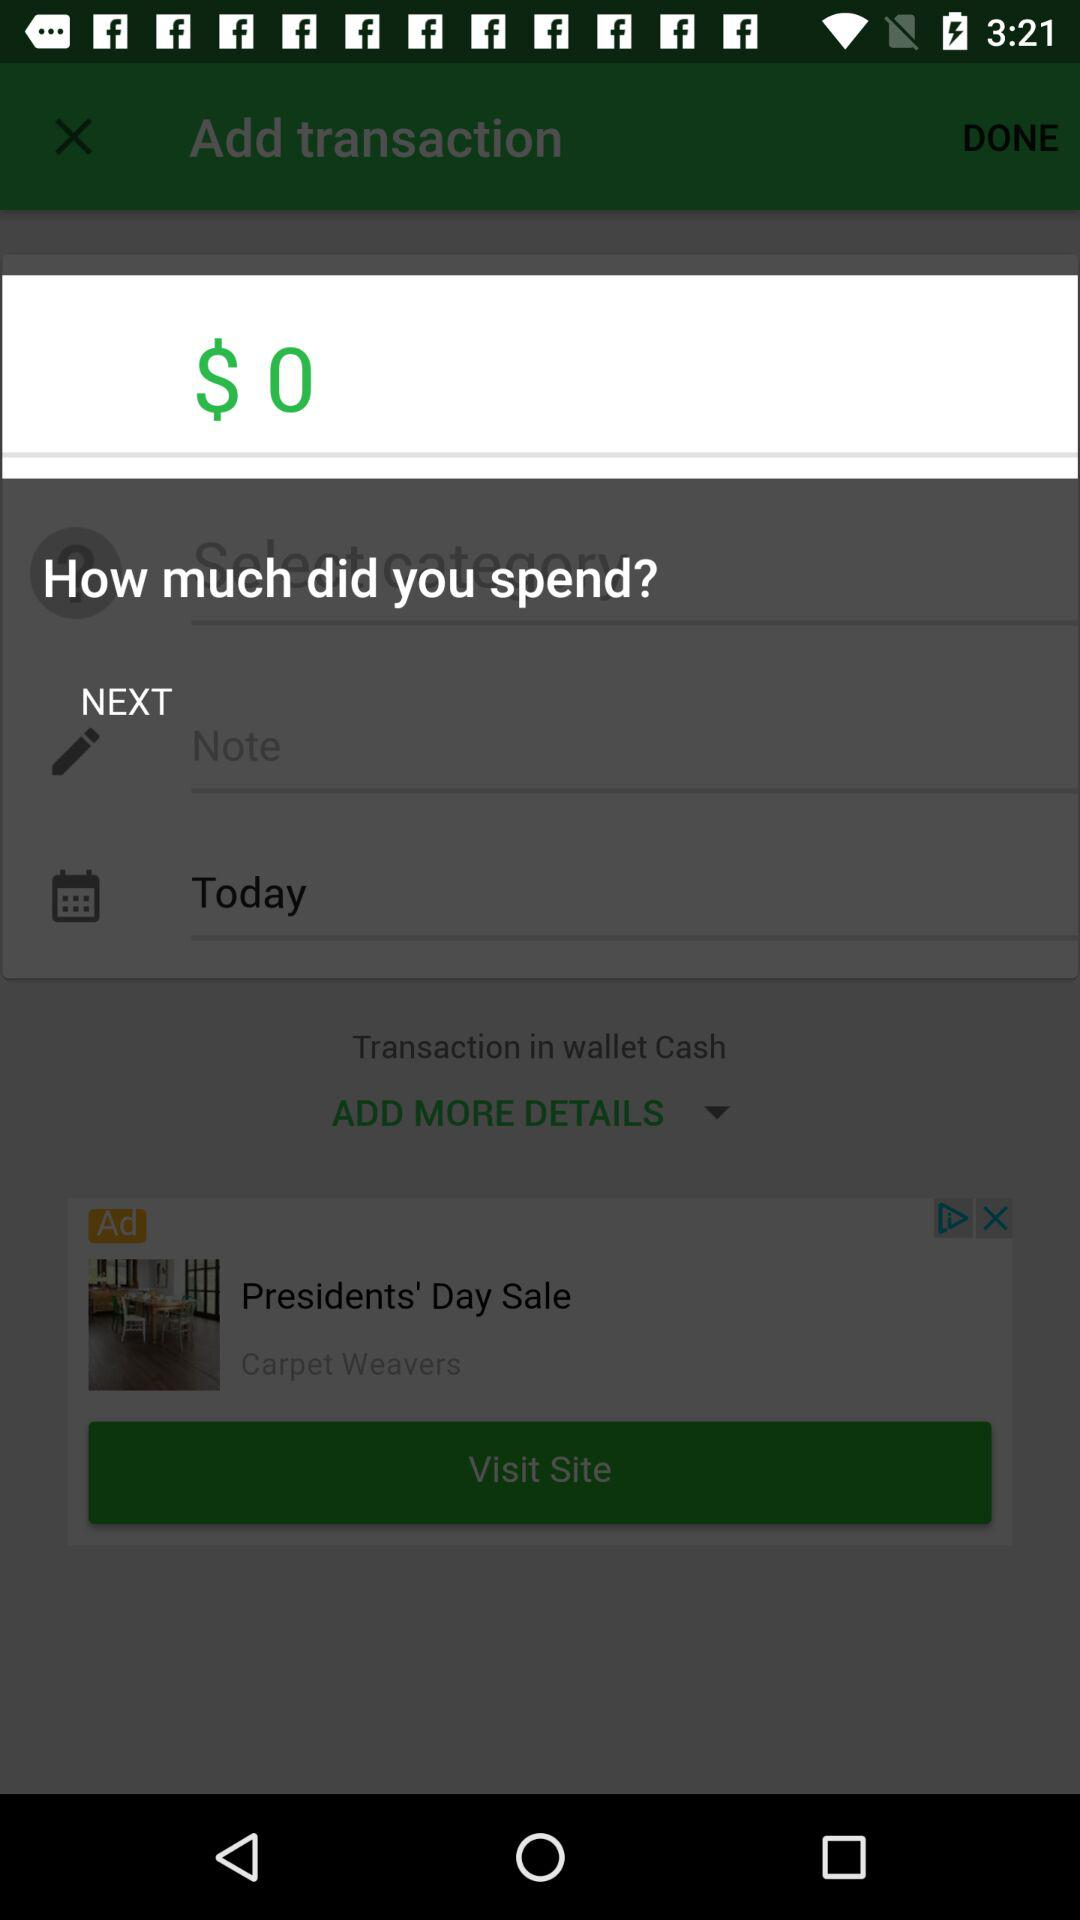How much did you spend today?
Answer the question using a single word or phrase. $0 